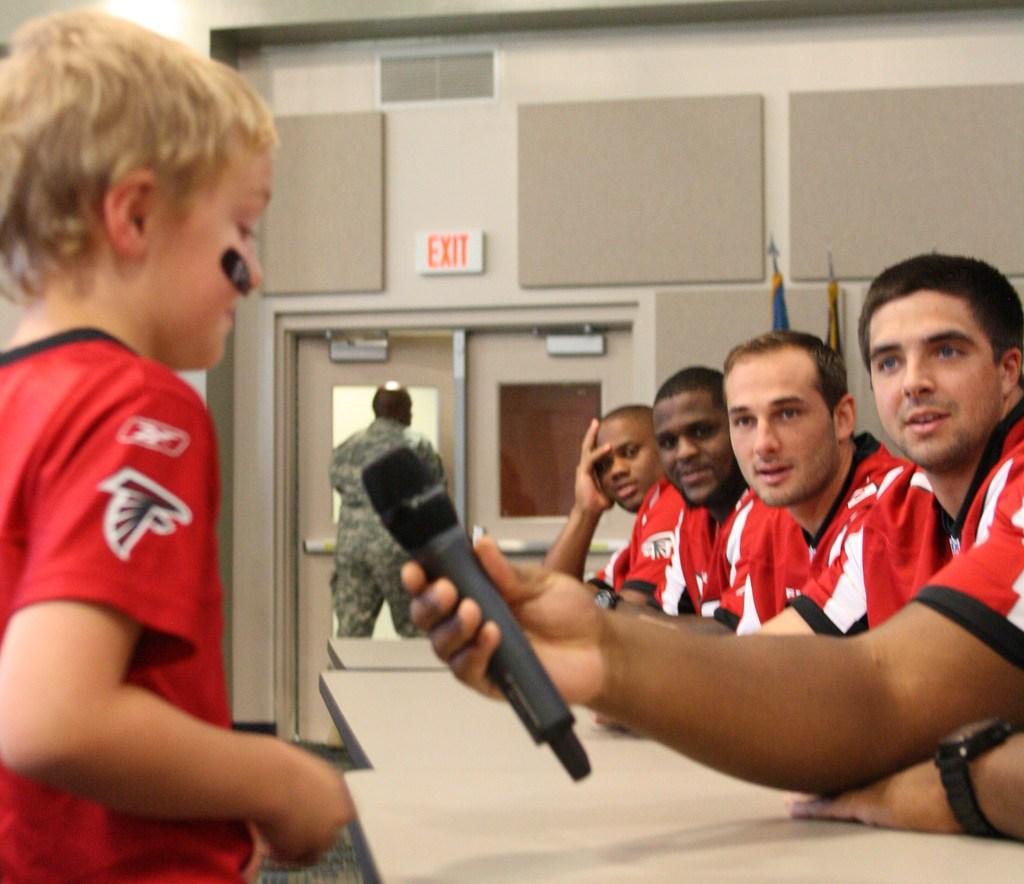What does the sign say above the door?
Keep it short and to the point. Exit. 